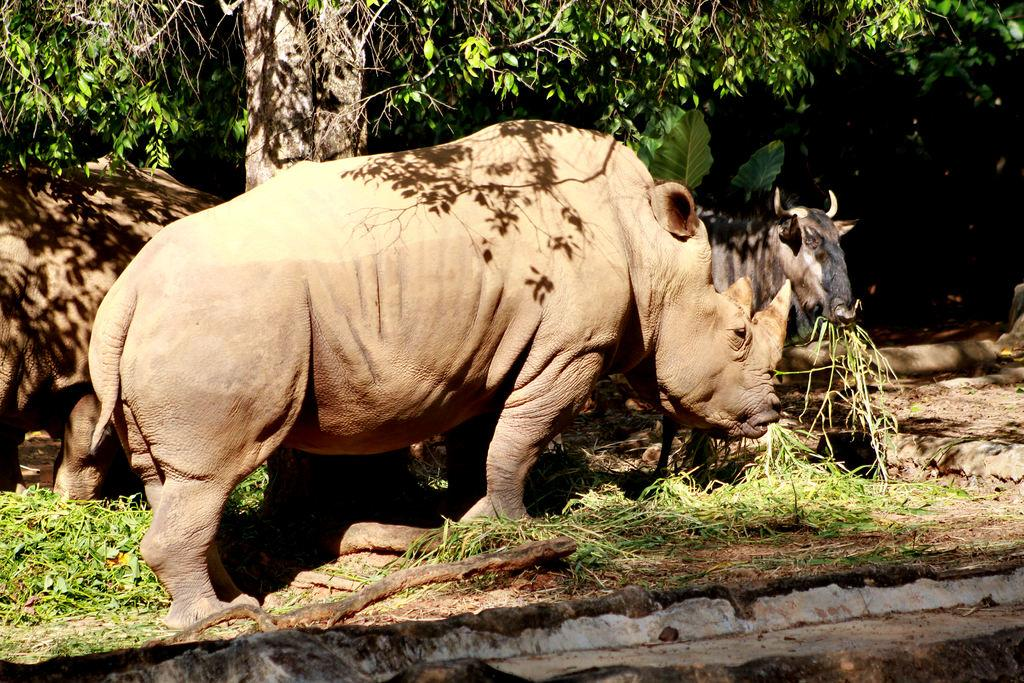What animals can be seen in the image? There is a rhinoceros and a buffalo in the image. What are the animals doing in the image? Both the rhinoceros and buffalo are eating grass. What can be seen on the ground in the image? The ground is visible in the image. What is visible in the background of the image? There is a tree and plants in the background of the image. What type of request can be seen being made by the turkey in the image? There is no turkey present in the image; it features a rhinoceros and a buffalo. 